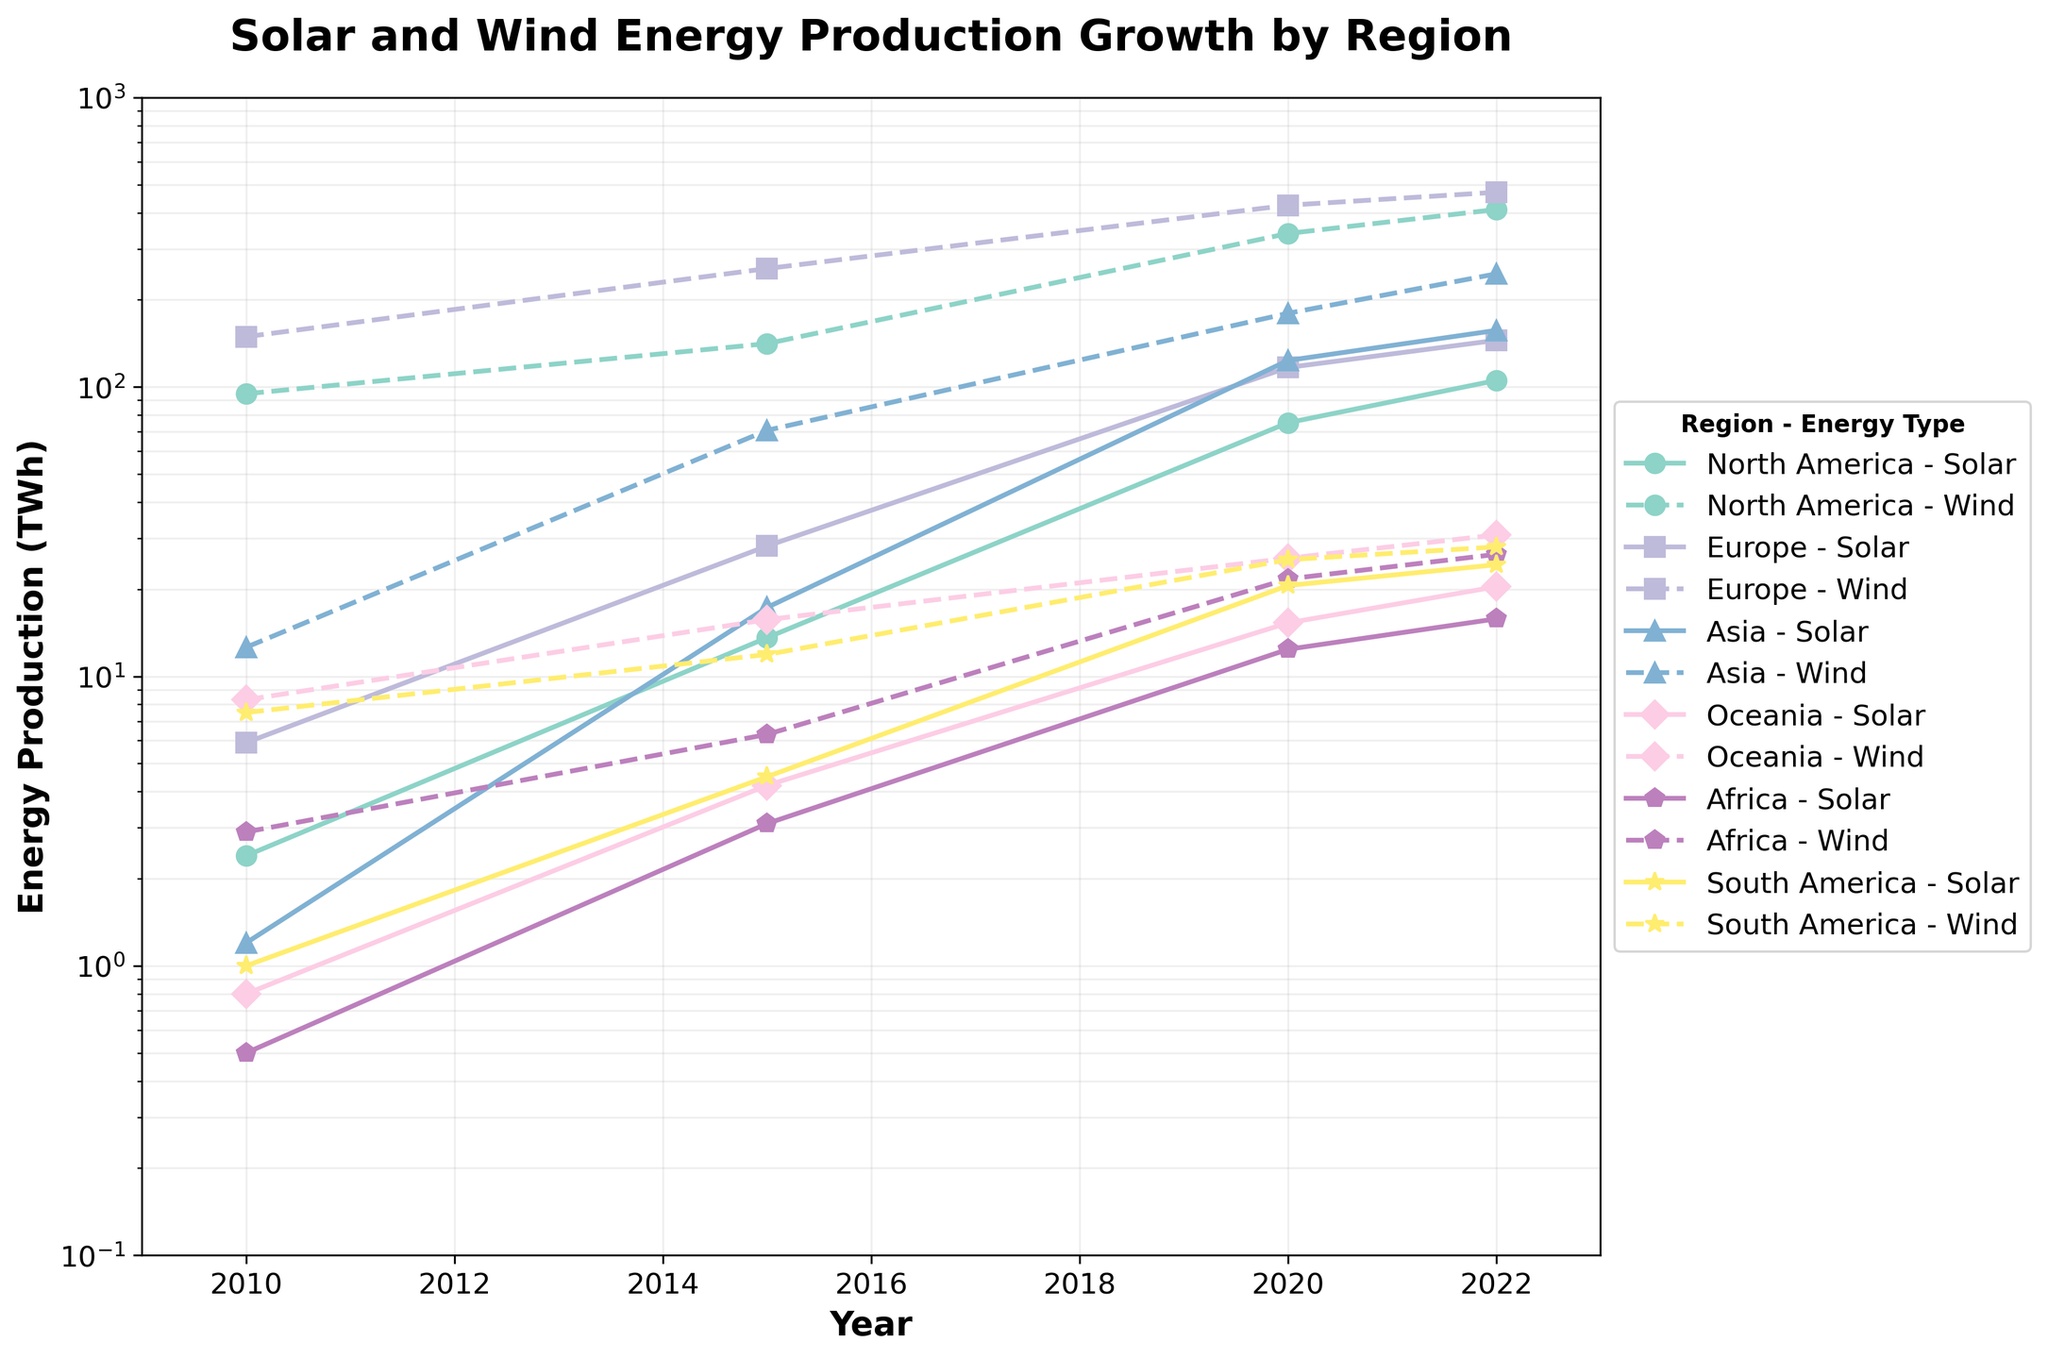What is the title of the plot? The title is displayed at the top of the figure and reads "Solar and Wind Energy Production Growth by Region".
Answer: Solar and Wind Energy Production Growth by Region Which region had the highest solar energy production in 2010? By looking at the solar energy production data points for 2010, Europe appears to have the highest value of around 5.9 TWh.
Answer: Europe How does the wind energy production in Asia in 2015 compare to North America in the same year? In 2015, Asia's wind energy production is around 70.8 TWh, while North America's wind energy production is higher, around 141.1 TWh.
Answer: North America is higher Between 2015 and 2022, which region exhibited the largest increase in solar energy production? Calculate the increase in solar energy production between 2015 and 2022 for each region. Europe increased from 28.2 to 144.9 TWh, which is the largest increase among all regions.
Answer: Europe Which region experienced the steepest growth in wind energy production from 2010 to 2022? By examining the steepness of the curves, Europe shows the most significant growth in wind energy production from 149.1 TWh in 2010 to 470.5 TWh in 2022.
Answer: Europe In 2022, which energy type (solar or wind) was more dominant in North America? The data in 2022 show that wind energy production in North America is at 410.2 TWh, while solar energy production is at 105.3 TWh. Wind energy is more dominant.
Answer: Wind For which region is the difference between solar and wind energy production in 2022 smallest? Compare the differences in solar and wind energy production for each region in 2022. Oceania has a solar energy production of 20.4 TWh and wind energy production of 30.8 TWh, making the difference 10.4 TWh, which is the smallest.
Answer: Oceania What is the y-axis scale of the plot? The y-axis is labeled "Energy Production (TWh)" and is set on a logarithmic scale. This is indicated by the log-scale increments in the axis values.
Answer: Logarithmic scale Between 2010 and 2022, which region had the lowest maximum energy production for both solar and wind combined? Compare the maximum combined energy production (solar + wind) for each region over the period 2010-2022. Africa has the lowest combined maximum production with 15.8 TWh (solar) + 26.4 TWh (wind) = 42.2 TWh in 2022.
Answer: Africa 